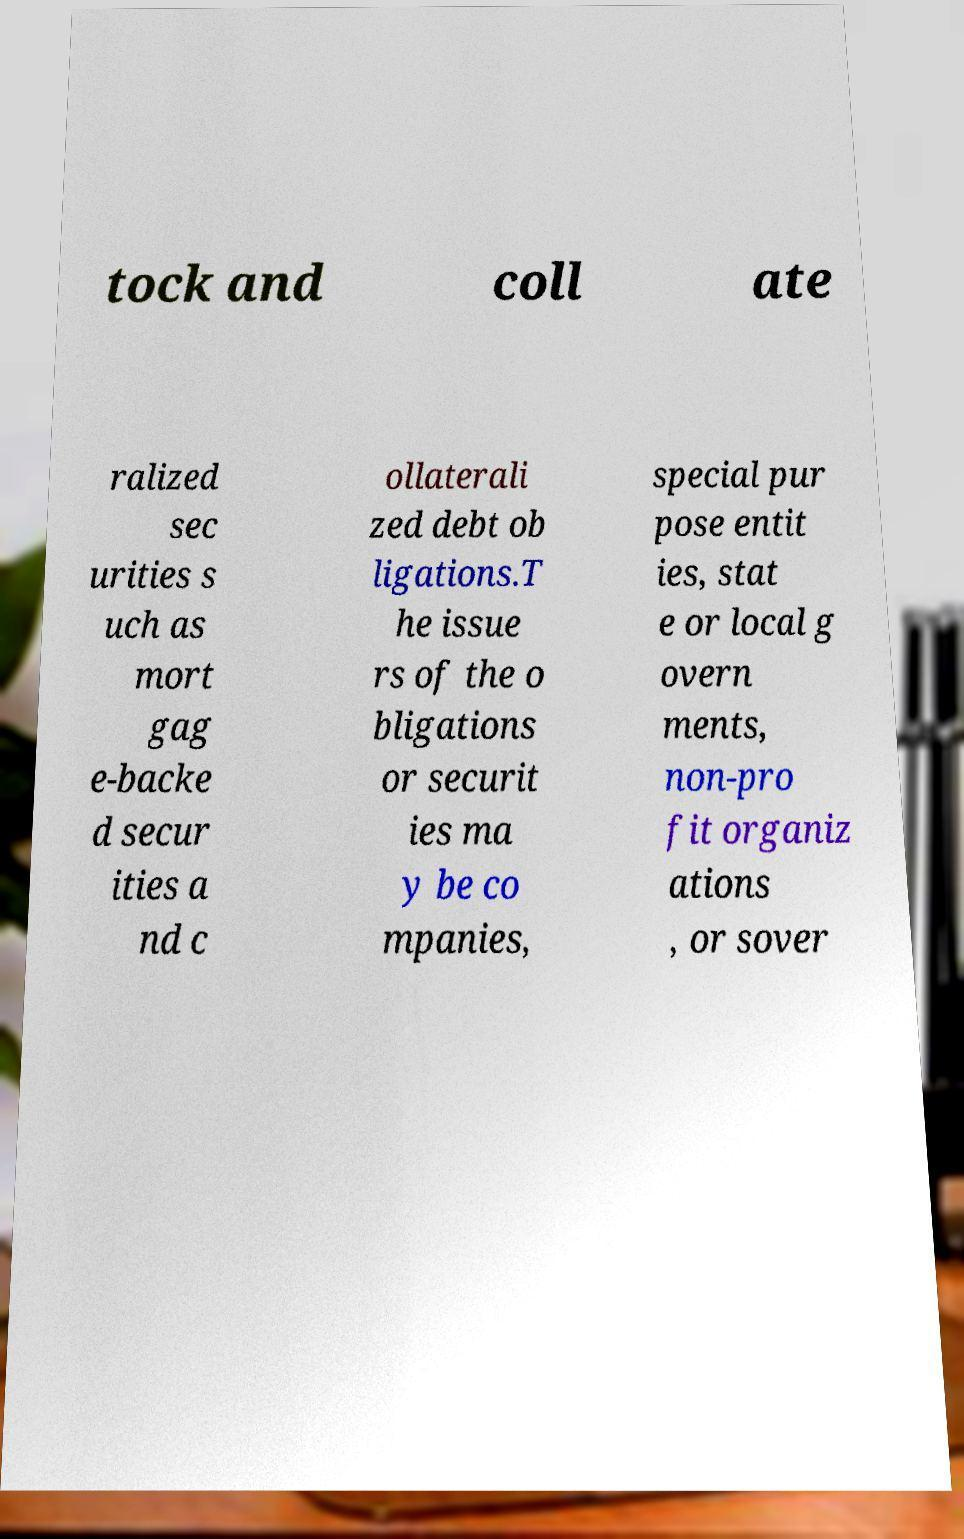Can you read and provide the text displayed in the image?This photo seems to have some interesting text. Can you extract and type it out for me? tock and coll ate ralized sec urities s uch as mort gag e-backe d secur ities a nd c ollaterali zed debt ob ligations.T he issue rs of the o bligations or securit ies ma y be co mpanies, special pur pose entit ies, stat e or local g overn ments, non-pro fit organiz ations , or sover 